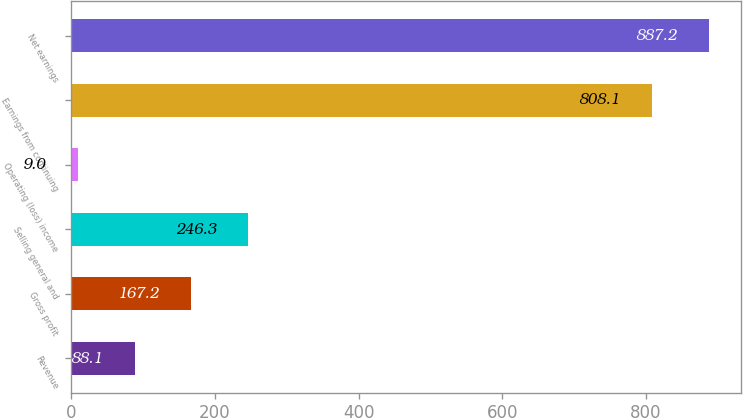Convert chart to OTSL. <chart><loc_0><loc_0><loc_500><loc_500><bar_chart><fcel>Revenue<fcel>Gross profit<fcel>Selling general and<fcel>Operating (loss) income<fcel>Earnings from continuing<fcel>Net earnings<nl><fcel>88.1<fcel>167.2<fcel>246.3<fcel>9<fcel>808.1<fcel>887.2<nl></chart> 